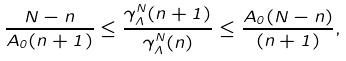<formula> <loc_0><loc_0><loc_500><loc_500>\frac { N - n } { A _ { 0 } ( n + 1 ) } \leq \frac { \gamma _ { \Lambda } ^ { N } ( n + 1 ) } { \gamma _ { \Lambda } ^ { N } ( n ) } \leq \frac { A _ { 0 } ( N - n ) } { ( n + 1 ) } ,</formula> 